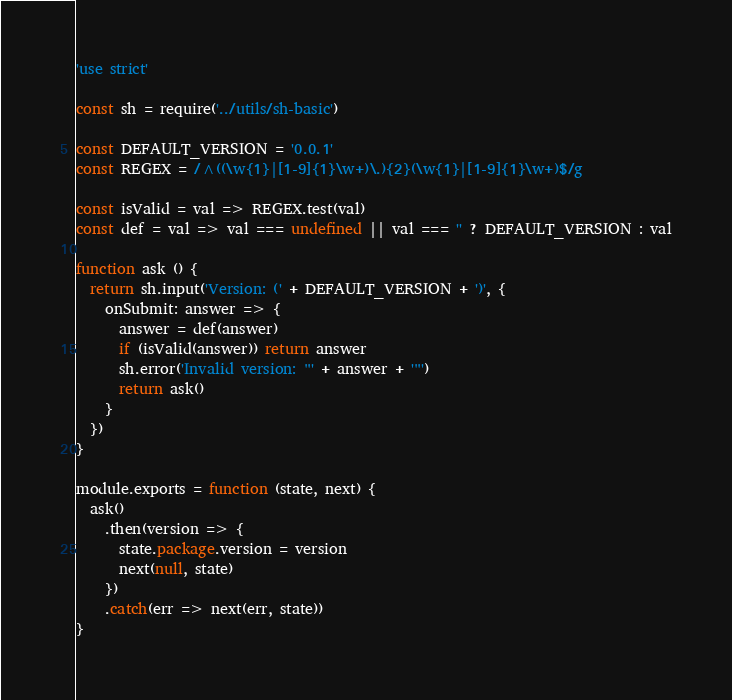<code> <loc_0><loc_0><loc_500><loc_500><_JavaScript_>'use strict'

const sh = require('../utils/sh-basic')

const DEFAULT_VERSION = '0.0.1'
const REGEX = /^((\w{1}|[1-9]{1}\w+)\.){2}(\w{1}|[1-9]{1}\w+)$/g

const isValid = val => REGEX.test(val)
const def = val => val === undefined || val === '' ? DEFAULT_VERSION : val

function ask () {
  return sh.input('Version: (' + DEFAULT_VERSION + ')', {
    onSubmit: answer => {
      answer = def(answer)
      if (isValid(answer)) return answer
      sh.error('Invalid version: "' + answer + '"')
      return ask()
    }
  })
}

module.exports = function (state, next) {
  ask()
    .then(version => {
      state.package.version = version
      next(null, state)
    })
    .catch(err => next(err, state))
}
</code> 